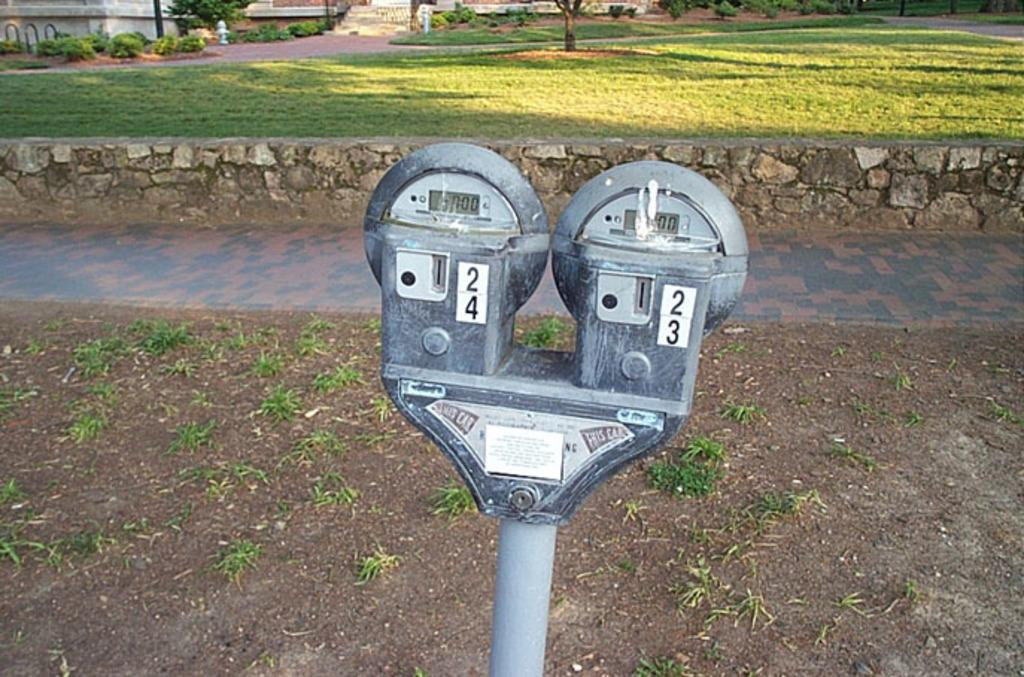<image>
Present a compact description of the photo's key features. Parking meters 24 and 23 are connected to each other on one pole. 